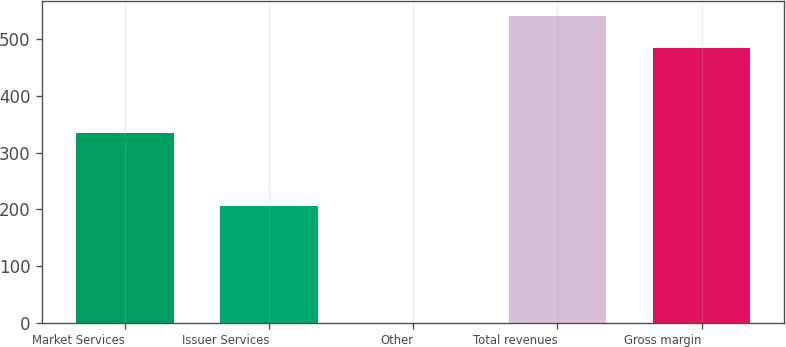Convert chart to OTSL. <chart><loc_0><loc_0><loc_500><loc_500><bar_chart><fcel>Market Services<fcel>Issuer Services<fcel>Other<fcel>Total revenues<fcel>Gross margin<nl><fcel>334.5<fcel>205.8<fcel>0.1<fcel>540.4<fcel>484.6<nl></chart> 